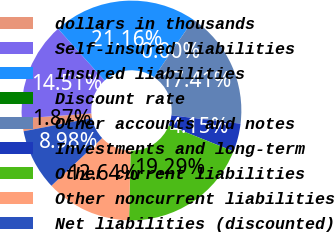<chart> <loc_0><loc_0><loc_500><loc_500><pie_chart><fcel>dollars in thousands<fcel>Self-insured liabilities<fcel>Insured liabilities<fcel>Discount rate<fcel>Other accounts and notes<fcel>Investments and long-term<fcel>Other current liabilities<fcel>Other noncurrent liabilities<fcel>Net liabilities (discounted)<nl><fcel>1.87%<fcel>14.51%<fcel>21.16%<fcel>0.0%<fcel>17.41%<fcel>4.15%<fcel>19.29%<fcel>12.64%<fcel>8.98%<nl></chart> 